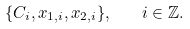Convert formula to latex. <formula><loc_0><loc_0><loc_500><loc_500>\{ C _ { i } , x _ { 1 , i } , x _ { 2 , i } \} , \quad i \in \mathbb { Z } .</formula> 